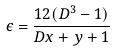<formula> <loc_0><loc_0><loc_500><loc_500>\epsilon = \frac { 1 2 ( D ^ { 3 } - 1 ) } { D x + y + 1 }</formula> 